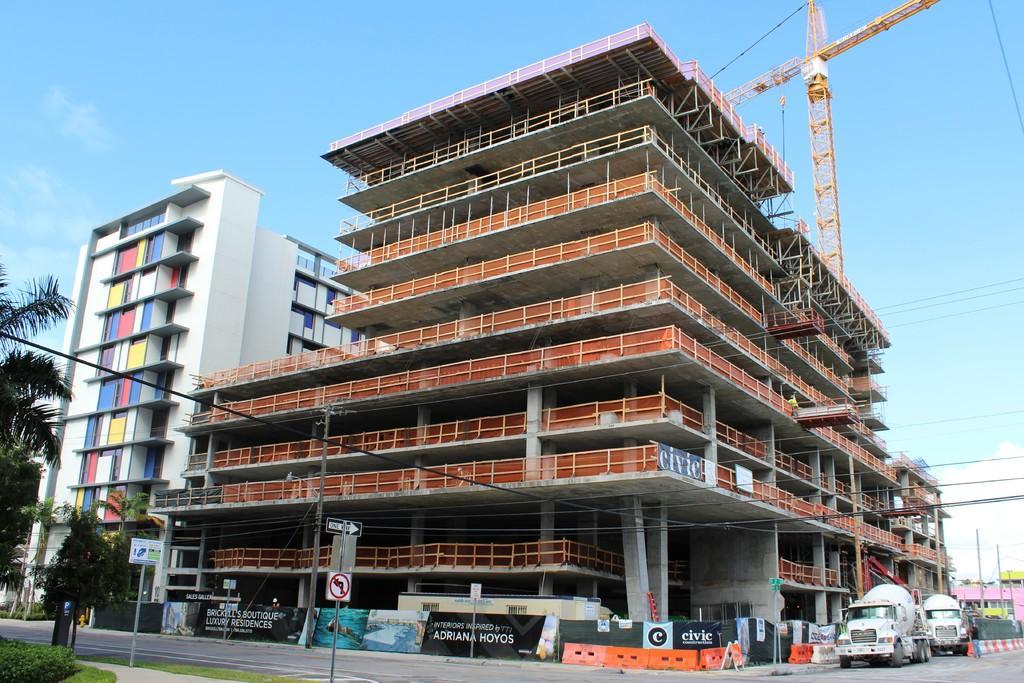Describe this image in one or two sentences. In this image there are buildings. At the bottom there is a road and we can see vehicles on the road. There are boards and sign boards. We can see trees and there is a crane. In the background there is sky. 